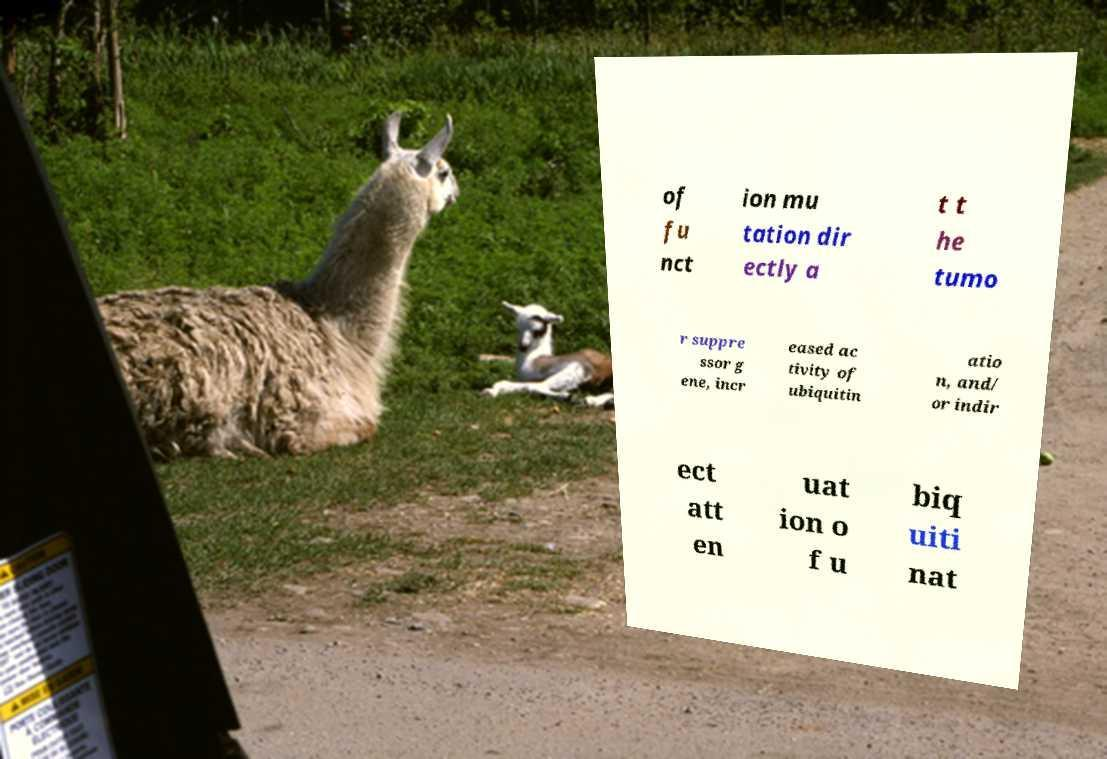Can you accurately transcribe the text from the provided image for me? of fu nct ion mu tation dir ectly a t t he tumo r suppre ssor g ene, incr eased ac tivity of ubiquitin atio n, and/ or indir ect att en uat ion o f u biq uiti nat 